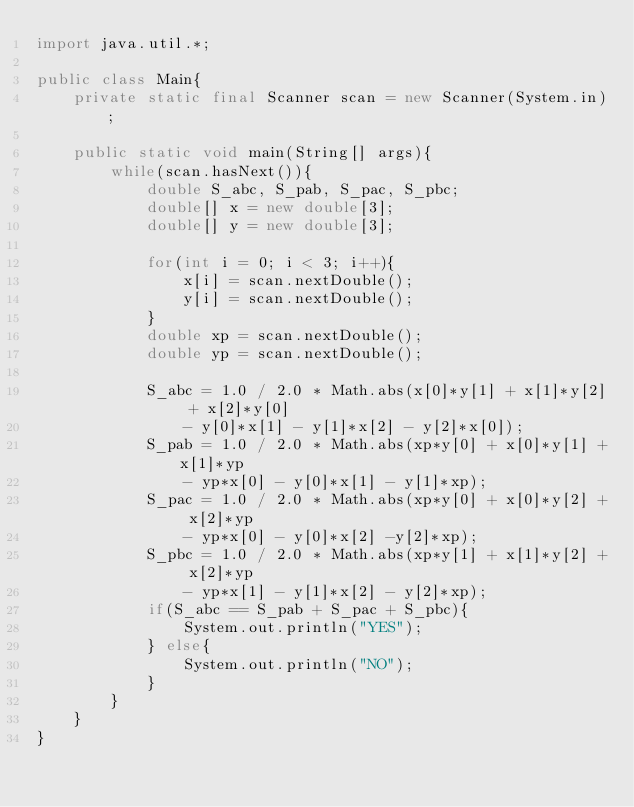<code> <loc_0><loc_0><loc_500><loc_500><_Java_>import java.util.*;

public class Main{
	private static final Scanner scan = new Scanner(System.in);

	public static void main(String[] args){
		while(scan.hasNext()){
			double S_abc, S_pab, S_pac, S_pbc;
			double[] x = new double[3];
			double[] y = new double[3];
			
			for(int i = 0; i < 3; i++){
				x[i] = scan.nextDouble();
				y[i] = scan.nextDouble();
			}
			double xp = scan.nextDouble();
			double yp = scan.nextDouble();

			S_abc = 1.0 / 2.0 * Math.abs(x[0]*y[1] + x[1]*y[2] + x[2]*y[0]
				- y[0]*x[1] - y[1]*x[2] - y[2]*x[0]);
			S_pab = 1.0 / 2.0 * Math.abs(xp*y[0] + x[0]*y[1] +x[1]*yp
				- yp*x[0] - y[0]*x[1] - y[1]*xp);
			S_pac = 1.0 / 2.0 * Math.abs(xp*y[0] + x[0]*y[2] + x[2]*yp
				- yp*x[0] - y[0]*x[2] -y[2]*xp);
			S_pbc = 1.0 / 2.0 * Math.abs(xp*y[1] + x[1]*y[2] + x[2]*yp
				- yp*x[1] - y[1]*x[2] - y[2]*xp);
			if(S_abc == S_pab + S_pac + S_pbc){
				System.out.println("YES");
			} else{
				System.out.println("NO");
			}
		}
	}
}</code> 